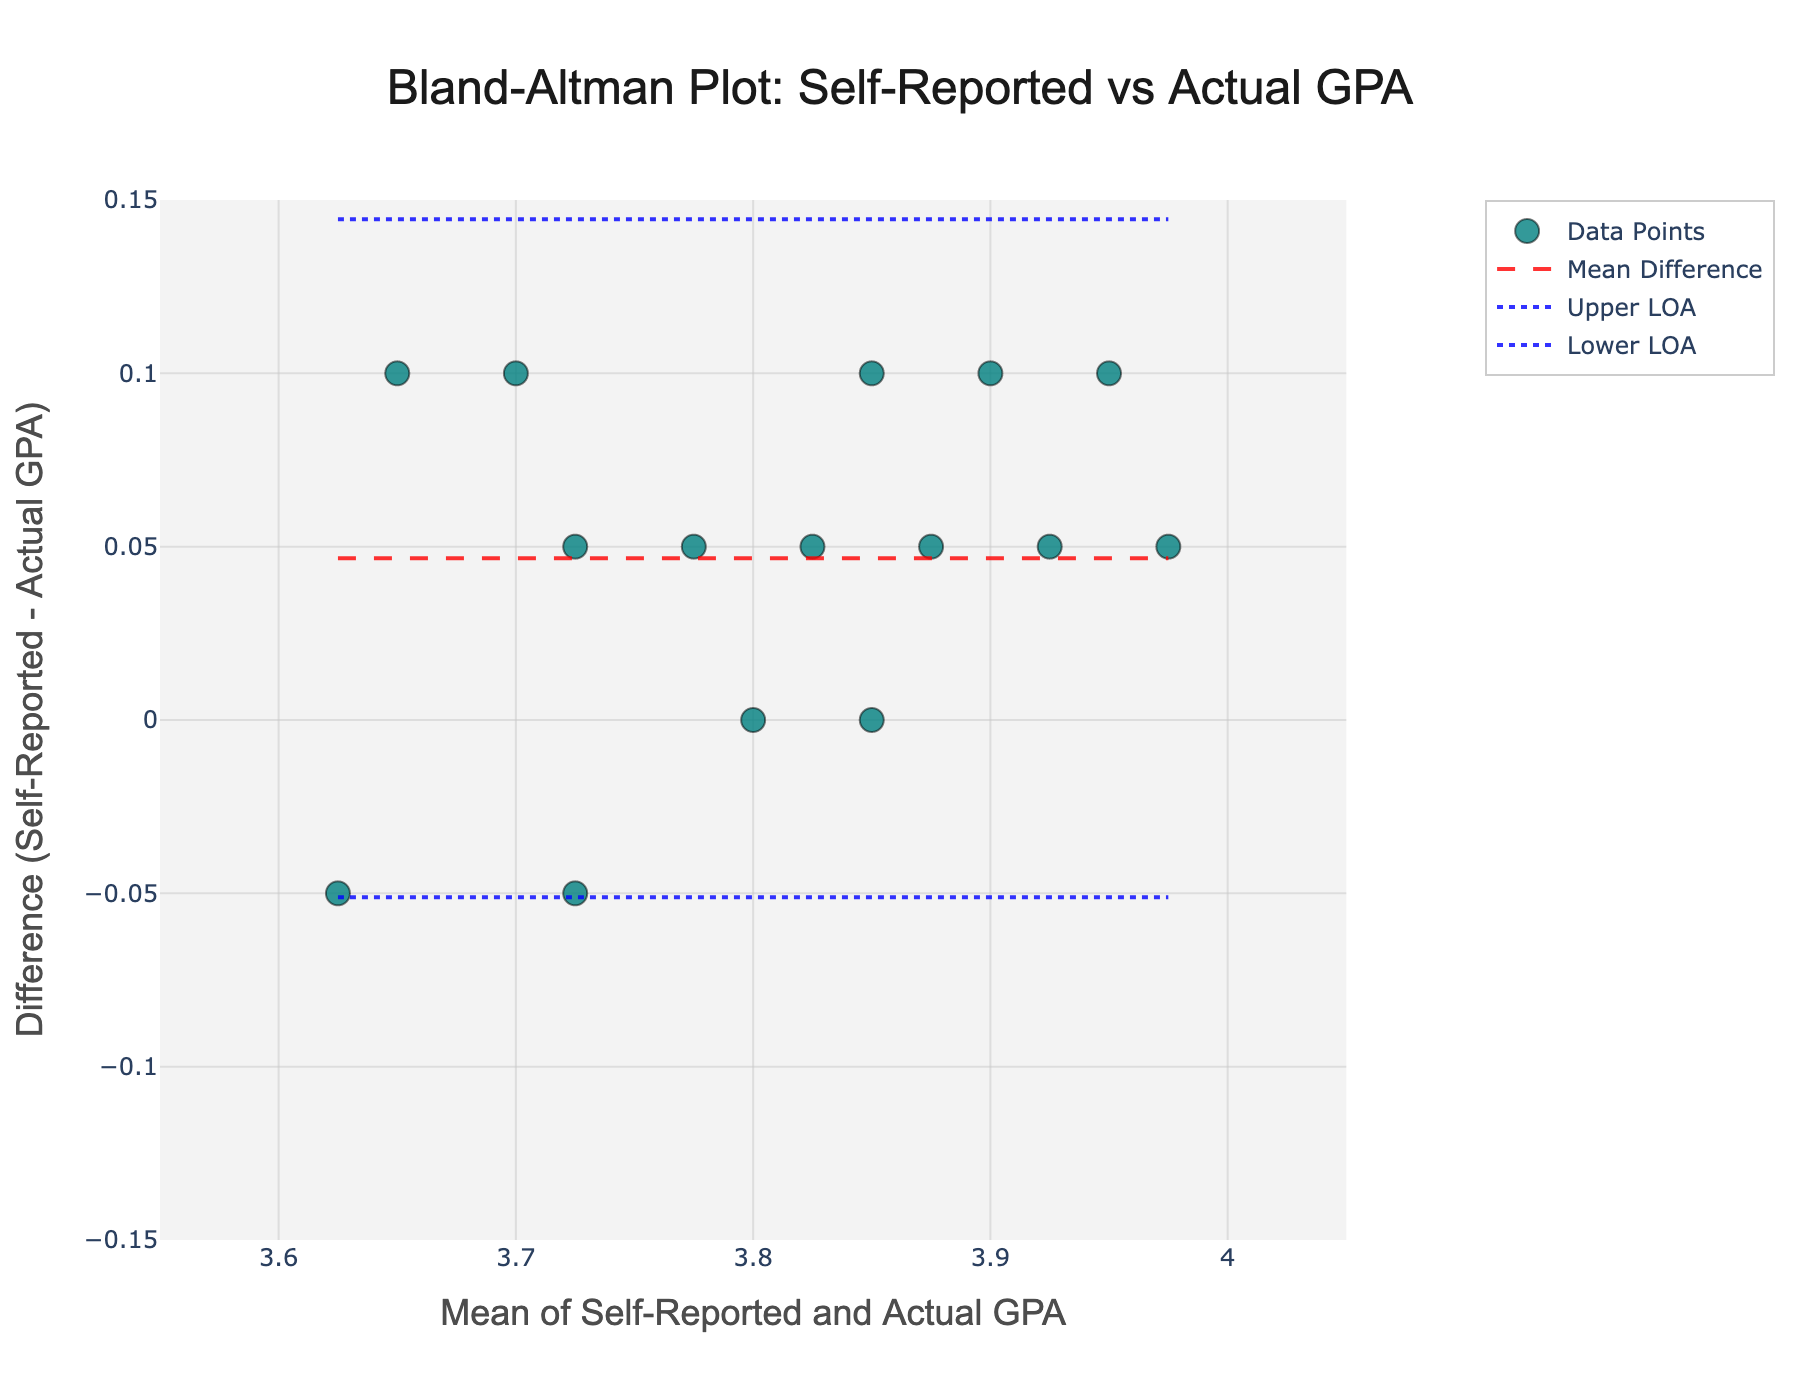What's the title of the figure? The title is displayed at the top center of the figure, clearly indicating the context of the data being represented. It is written as: 'Bland-Altman Plot: Self-Reported vs Actual GPA'.
Answer: Bland-Altman Plot: Self-Reported vs Actual GPA What is the mean difference between self-reported and actual GPA? This can be observed from the horizontal dashed red line across the middle of the plot. The mean difference value is labeled to assist visualization.
Answer: Around 0.02 What do the blue dotted lines represent? In a Bland-Altman plot, the lines above and below the mean difference indicate the limits of agreement. These limits are typically at ±1.96 times the standard deviation of the differences. Here, the blue dotted lines represent these upper and lower limits of agreement.
Answer: Limits of Agreement How many data points are plotted? Each data point represents a pair of self-reported and actual GPA values. You can count each marker in the scatter plot.
Answer: 15 data points What is the y-value for the data point with the lowest mean GPA? Locate the data point with the smallest x-value (mean GPA) and then check its y-value (difference GPA). The leftmost data point has a mean GPA of 3.6 and a difference of 0.05.
Answer: 0.05 Are there any data points where the self-reported GPA equals the actual GPA? For self-reported GPA to equal actual GPA, their mean difference (y-value) should be 0. Look for any points on the y=0 line. One such point is visible around mean 3.85.
Answer: Yes How does the mean GPA appear to affect the difference between self-reported and actual GPAs? By examining the distribution of points, particularly where the mean GPA is on the x-axis and the difference is on the y-axis, one can infer trends. It appears that the self-reported GPAs consistently report slightly higher or the same values compared to the actual GPAs.
Answer: Minimal effect, mostly positive differences Which data point shows the maximum positive difference between self-reported and actual GPA? Identify the point with the highest y-value (difference) and check its coordinates. Here, the highest positive difference is 0.1 at a mean GPA of around 3.65.
Answer: Mean GPA around 3.65, difference 0.1 What is the significance of the dashed red line on the plot? The dashed red line represents the mean difference between self-reported and actual GPAs. This average provides insight into any systematic bias in the self-reported values.
Answer: Mean difference between GPAs 